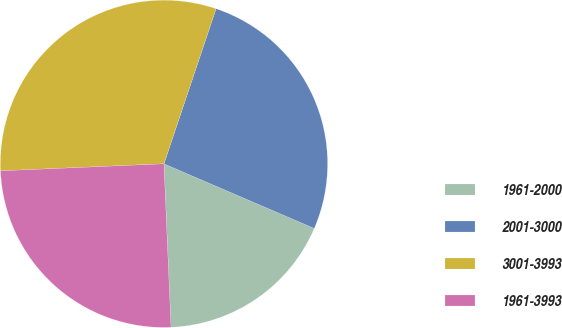Convert chart to OTSL. <chart><loc_0><loc_0><loc_500><loc_500><pie_chart><fcel>1961-2000<fcel>2001-3000<fcel>3001-3993<fcel>1961-3993<nl><fcel>17.85%<fcel>26.3%<fcel>30.84%<fcel>25.0%<nl></chart> 